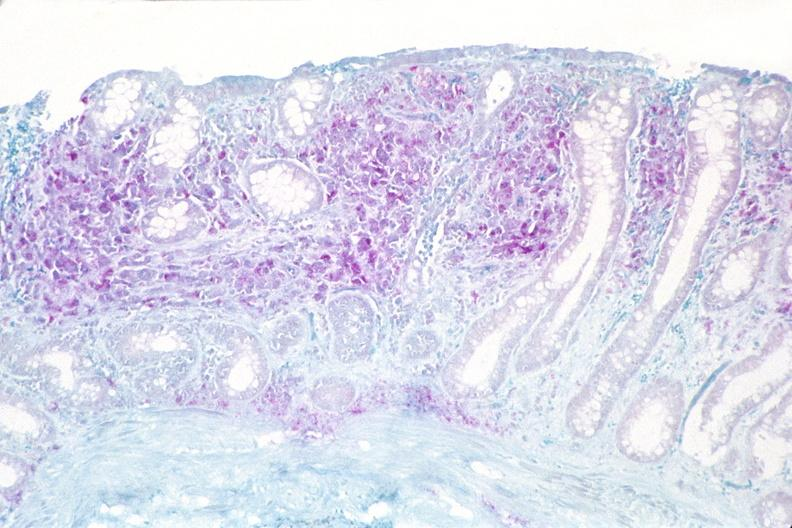where is this from?
Answer the question using a single word or phrase. Gastrointestinal system 